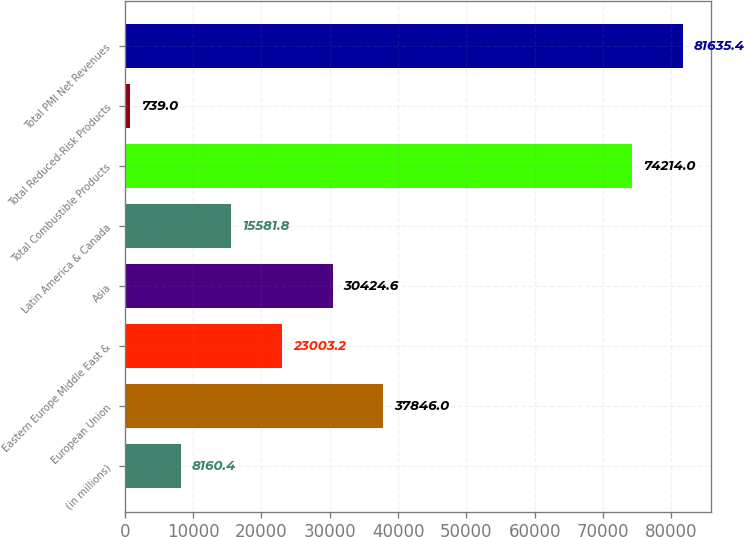Convert chart to OTSL. <chart><loc_0><loc_0><loc_500><loc_500><bar_chart><fcel>(in millions)<fcel>European Union<fcel>Eastern Europe Middle East &<fcel>Asia<fcel>Latin America & Canada<fcel>Total Combustible Products<fcel>Total Reduced-Risk Products<fcel>Total PMI Net Revenues<nl><fcel>8160.4<fcel>37846<fcel>23003.2<fcel>30424.6<fcel>15581.8<fcel>74214<fcel>739<fcel>81635.4<nl></chart> 